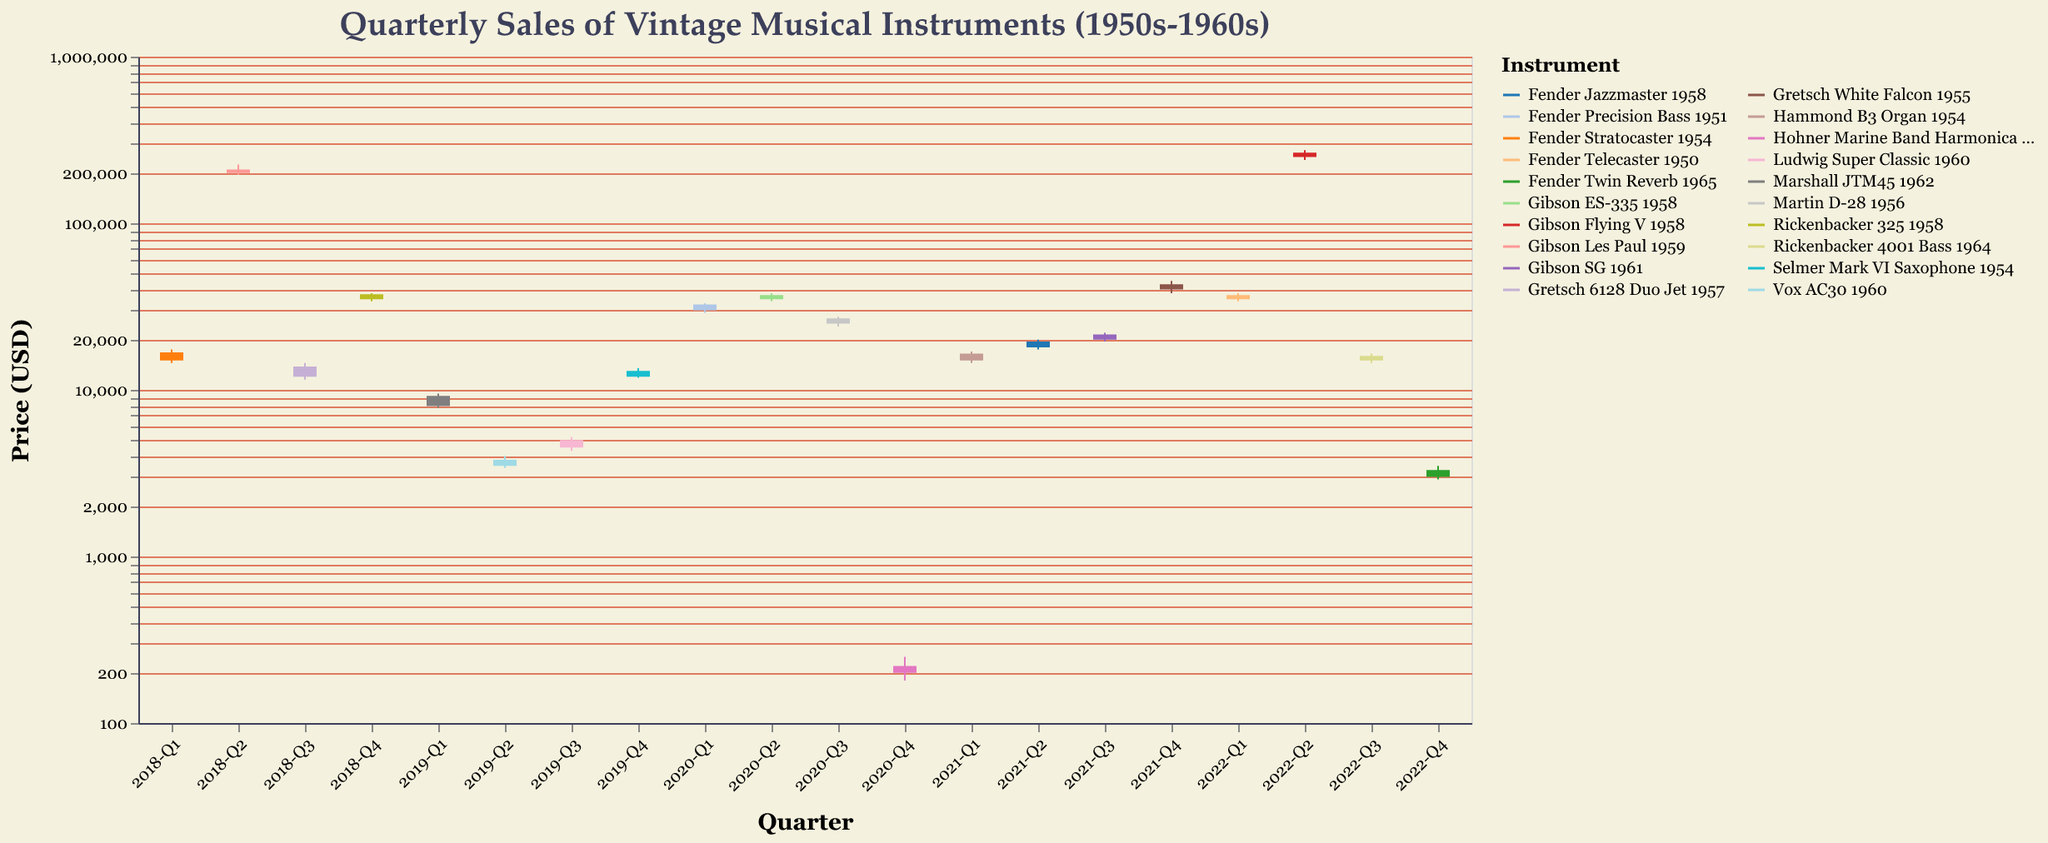Which instrument had the highest closing price in the entire dataset? To find the highest closing price, scan through the "Close" values. The Gibson Flying V 1958 closed at $265,000 in 2022-Q2, the highest in the dataset.
Answer: Gibson Flying V 1958 Which instrument showed the largest range in price in any quarter? For each instrument, calculate the range as High - Low for each quarter. The Gibson Les Paul 1959 had prices ranging from $195,000 to $225,000 in 2018-Q2, which is a $30,000 range.
Answer: Gibson Les Paul 1959 How did the closing price of the Fender Stratocaster 1954 change from 2018-Q1 to 2018-Q4? Note the closing price of the Fender Stratocaster 1954 in 2018-Q1 ($16,800). Then, find its closing price in 2018-Q4 but notice that there's no data for it in 2018-Q4; thus, we can only observe its first quarter closure.
Answer: No data after 2018-Q1 Which quarter recorded the lowest opening price, and for which instrument? Scan through the "Open" prices for each quarter and find the lowest value. The Hohner Marine Band Harmonica 1950 opened at $200 in 2020-Q4, the lowest in the dataset.
Answer: 2020-Q4, Hohner Marine Band Harmonica 1950 What was the price trend for the Gretsch White Falcon 1955 in 2021-Q4? Did the price increase or decrease by the end of the quarter? Look at the open, high, low, and close prices for 2021-Q4. The Gretsch White Falcon 1955 opened at $40,000 and closed at $43,000, showing an increase.
Answer: Increased Which instrument had the highest volatility in 2019? Calculate the volatility for each instrument in 2019 by finding the difference between the high and low prices in each quarter. The Marshall JTM45 1962 had the highest volatility with a range of $1,700 in 2019-Q1 ($9,500 - $7,800).
Answer: Marshall JTM45 1962 How many instruments had a closing price above $20,000 at any point over the 5 years? Scan through the "Close" column and count each instrument/quarter where the closing price was above $20,000. Instruments that match include Gibson Les Paul 1959, Gretsch White Falcon 1955, etc., resulting in 8 occasions.
Answer: 8 occasions What is the average closing price of the Fender Telecaster 1950 over the quarter it appeared? The Fender Telecaster 1950 appeared in 2022-Q1 with a closing price of $37,000. It’s the only data point for this instrument, so the average is $37,000.
Answer: $37,000 